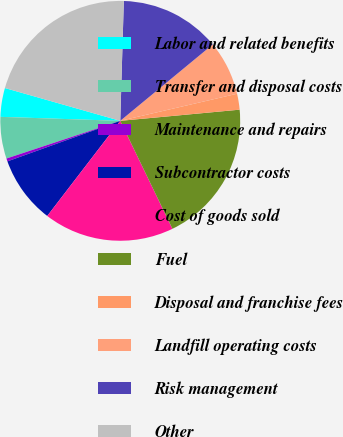Convert chart. <chart><loc_0><loc_0><loc_500><loc_500><pie_chart><fcel>Labor and related benefits<fcel>Transfer and disposal costs<fcel>Maintenance and repairs<fcel>Subcontractor costs<fcel>Cost of goods sold<fcel>Fuel<fcel>Disposal and franchise fees<fcel>Landfill operating costs<fcel>Risk management<fcel>Other<nl><fcel>3.88%<fcel>5.62%<fcel>0.4%<fcel>9.09%<fcel>17.58%<fcel>19.32%<fcel>2.14%<fcel>7.36%<fcel>13.54%<fcel>21.06%<nl></chart> 